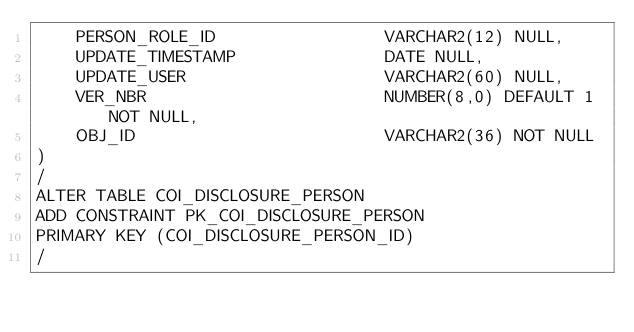<code> <loc_0><loc_0><loc_500><loc_500><_SQL_>    PERSON_ROLE_ID                 VARCHAR2(12) NULL,
    UPDATE_TIMESTAMP               DATE NULL,
    UPDATE_USER                    VARCHAR2(60) NULL,
    VER_NBR                        NUMBER(8,0) DEFAULT 1 NOT NULL,
    OBJ_ID                         VARCHAR2(36) NOT NULL
)
/
ALTER TABLE COI_DISCLOSURE_PERSON 
ADD CONSTRAINT PK_COI_DISCLOSURE_PERSON 
PRIMARY KEY (COI_DISCLOSURE_PERSON_ID)
/
</code> 